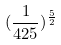Convert formula to latex. <formula><loc_0><loc_0><loc_500><loc_500>( \frac { 1 } { 4 2 5 } ) ^ { \frac { 5 } { 2 } }</formula> 